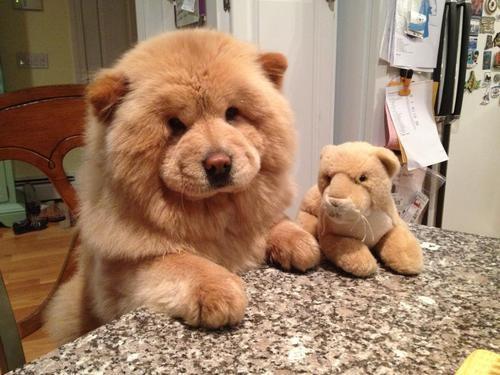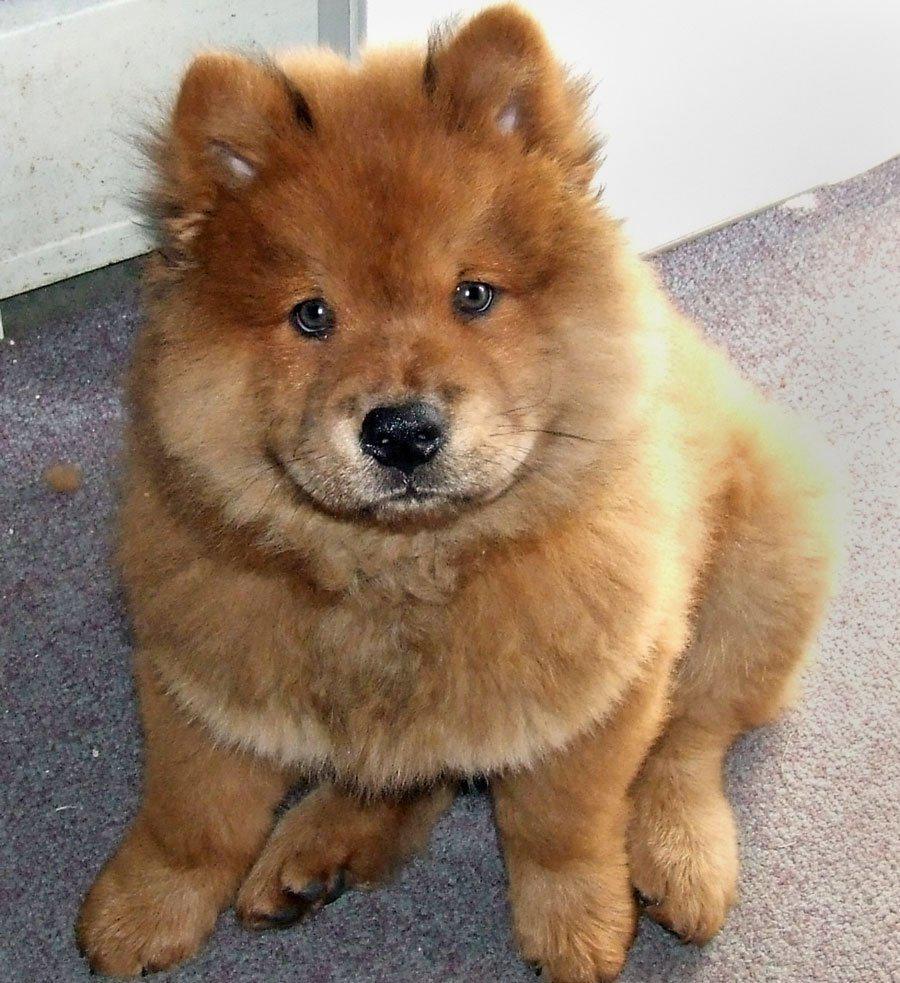The first image is the image on the left, the second image is the image on the right. Assess this claim about the two images: "The dogs in both images are sticking their tongues out.". Correct or not? Answer yes or no. No. The first image is the image on the left, the second image is the image on the right. Given the left and right images, does the statement "Two dogs have their mouths open and tongues sticking out." hold true? Answer yes or no. No. 